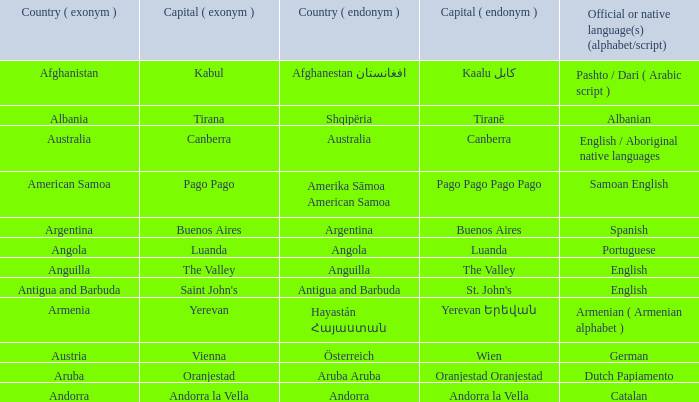How many capital cities does Australia have? 1.0. 